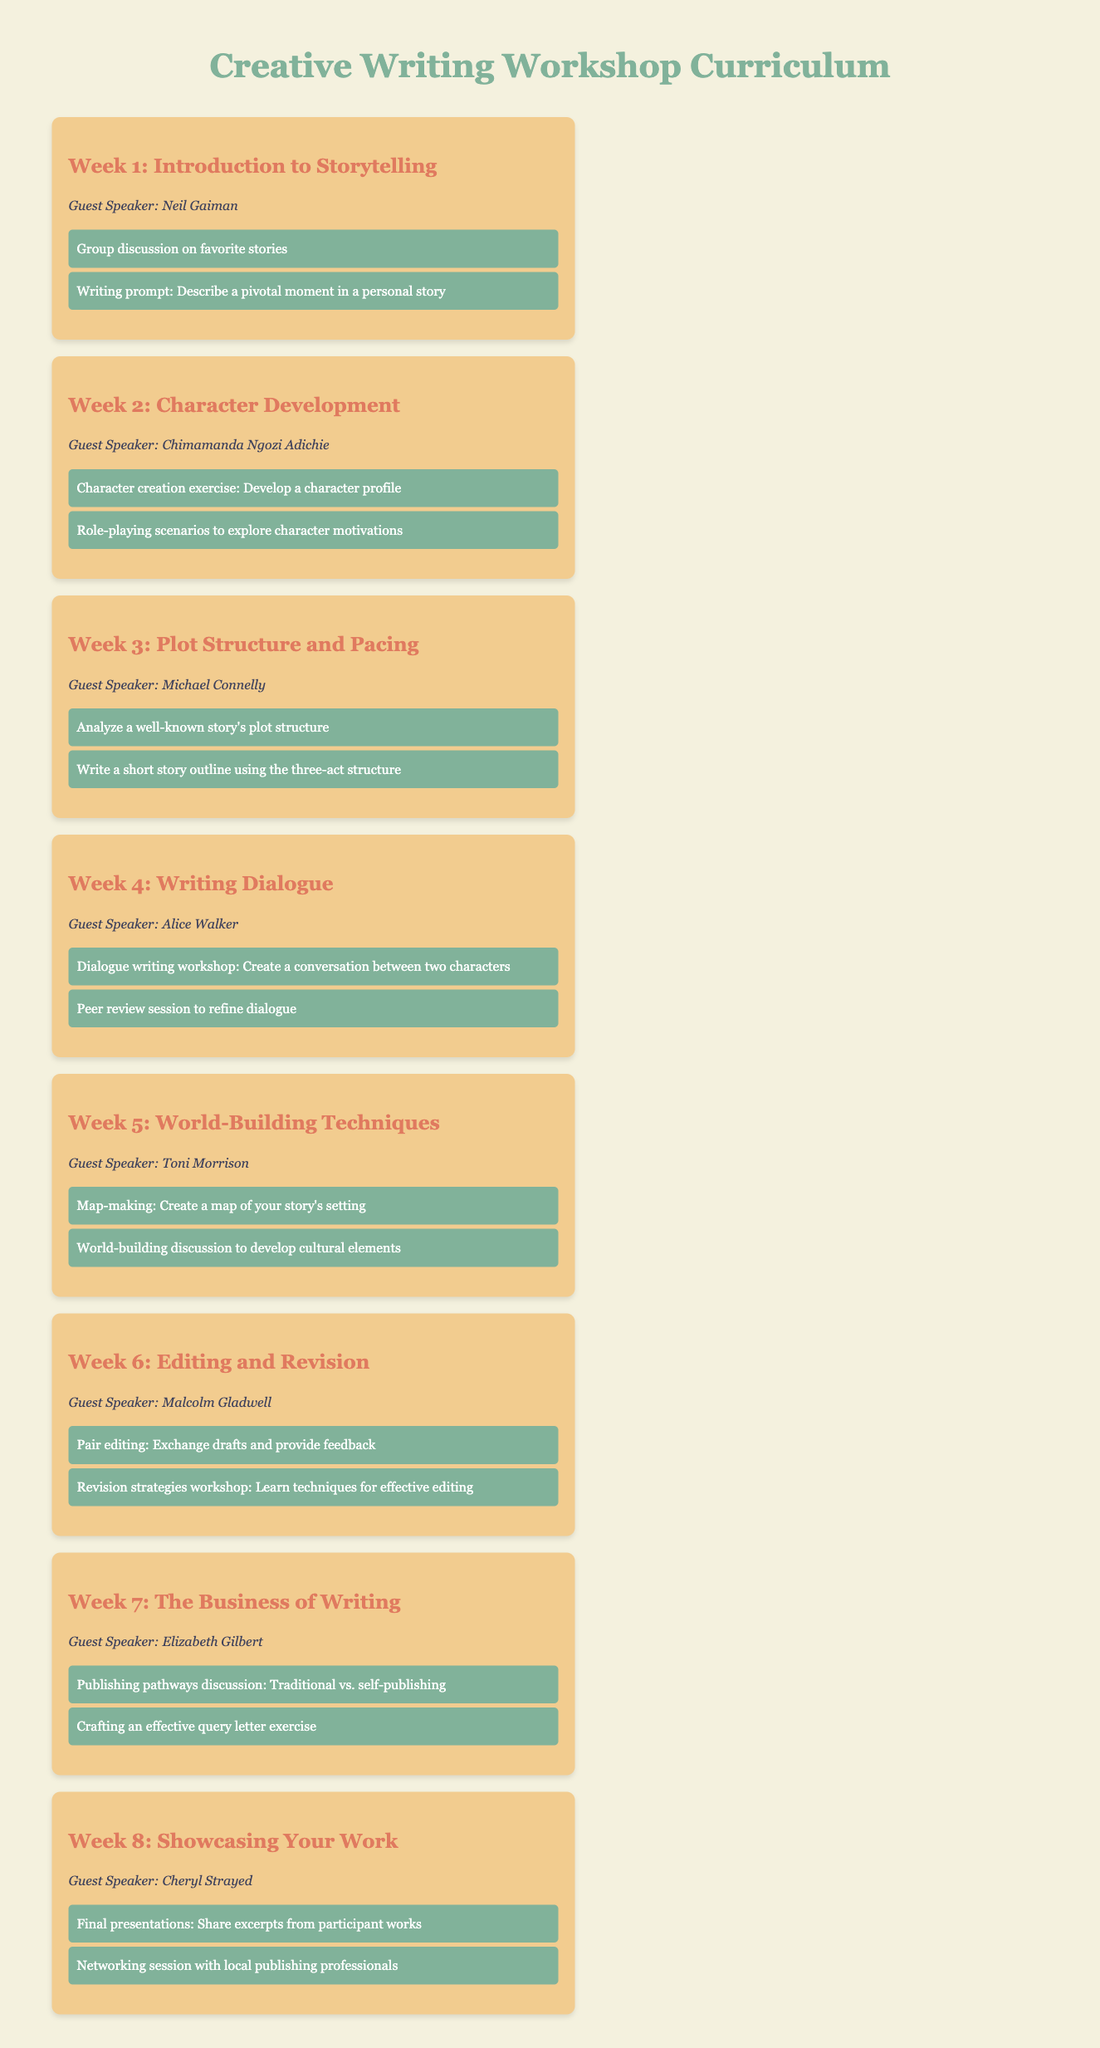What is the title of the workshop? The title of the workshop is prominently featured at the top of the document.
Answer: Creative Writing Workshop Curriculum Who is the guest speaker for Week 3? The guest speaker for Week 3 is listed in the respective week card section of the document.
Answer: Michael Connelly How many weeks does the workshop span? The total number of week cards in the document indicates the span of the workshop.
Answer: 8 Which activity involves creating a character profile? The specific activity is detailed in the Week 2 section of the document.
Answer: Character creation exercise What is the focus of Week 5? The main topic is explicitly stated in the title of the Week 5 card.
Answer: World-Building Techniques Who are the speakers for the first two weeks? The names of the guest speakers for these weeks can be found in the respective weeks.
Answer: Neil Gaiman, Chimamanda Ngozi Adichie What type of session is held in Week 6? The specific type of session can be found in the Week 6 activities list.
Answer: Pair editing What is one of the activities for the final week? The activities for the final week are listed in the respective week card section.
Answer: Final presentations 